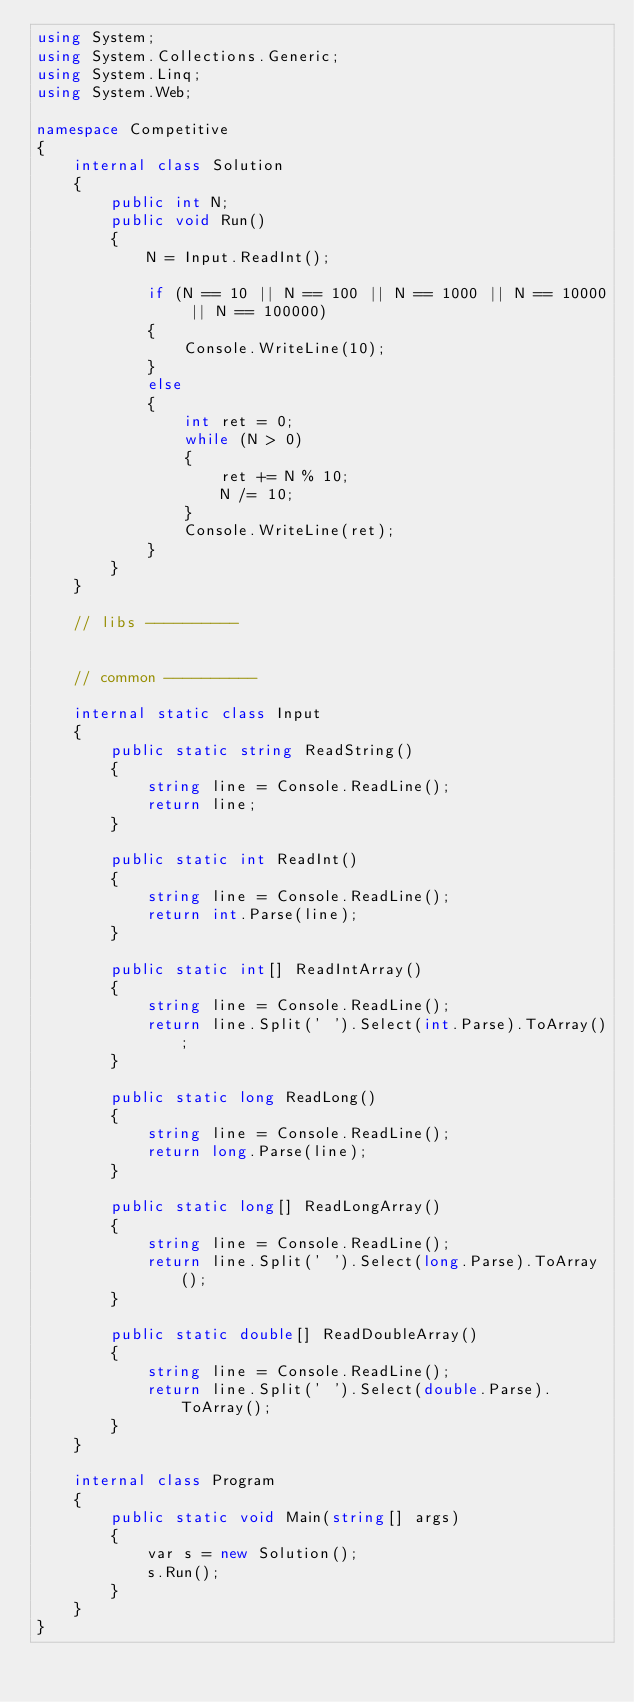<code> <loc_0><loc_0><loc_500><loc_500><_C#_>using System;
using System.Collections.Generic;
using System.Linq;
using System.Web;

namespace Competitive
{
    internal class Solution
    {
        public int N;
        public void Run()
        {
            N = Input.ReadInt();

            if (N == 10 || N == 100 || N == 1000 || N == 10000 || N == 100000)
            {
                Console.WriteLine(10);
            }
            else
            {
                int ret = 0;
                while (N > 0)
                {
                    ret += N % 10;
                    N /= 10;
                }
                Console.WriteLine(ret);
            }
        }
    }

    // libs ----------
    

    // common ----------

    internal static class Input
    {
        public static string ReadString()
        {
            string line = Console.ReadLine();
            return line;
        }

        public static int ReadInt()
        {
            string line = Console.ReadLine();
            return int.Parse(line);
        }

        public static int[] ReadIntArray()
        {
            string line = Console.ReadLine();
            return line.Split(' ').Select(int.Parse).ToArray();            
        }

        public static long ReadLong()
        {
            string line = Console.ReadLine();
            return long.Parse(line);
        }

        public static long[] ReadLongArray()
        {
            string line = Console.ReadLine();
            return line.Split(' ').Select(long.Parse).ToArray();
        }

        public static double[] ReadDoubleArray()
        {
            string line = Console.ReadLine();
            return line.Split(' ').Select(double.Parse).ToArray();
        }
    }
    
    internal class Program
    {
        public static void Main(string[] args)
        {
            var s = new Solution();
            s.Run();
        }
    }
}</code> 